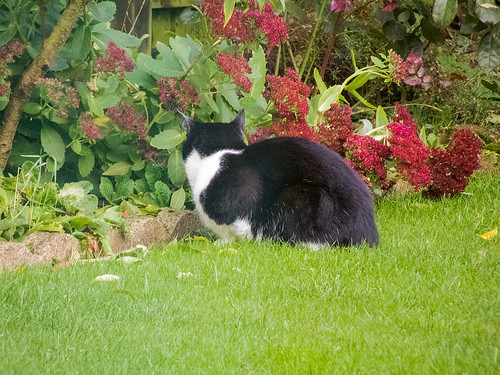<image>
Is the kitty behind the plant? No. The kitty is not behind the plant. From this viewpoint, the kitty appears to be positioned elsewhere in the scene. 